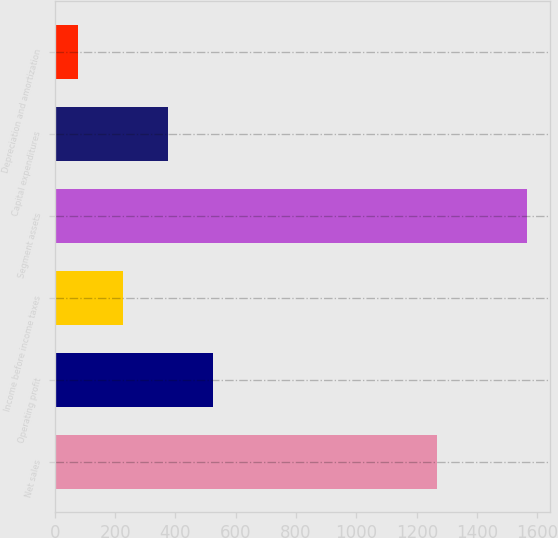Convert chart. <chart><loc_0><loc_0><loc_500><loc_500><bar_chart><fcel>Net sales<fcel>Operating profit<fcel>Income before income taxes<fcel>Segment assets<fcel>Capital expenditures<fcel>Depreciation and amortization<nl><fcel>1266.4<fcel>523.03<fcel>225.61<fcel>1564<fcel>374.32<fcel>76.9<nl></chart> 